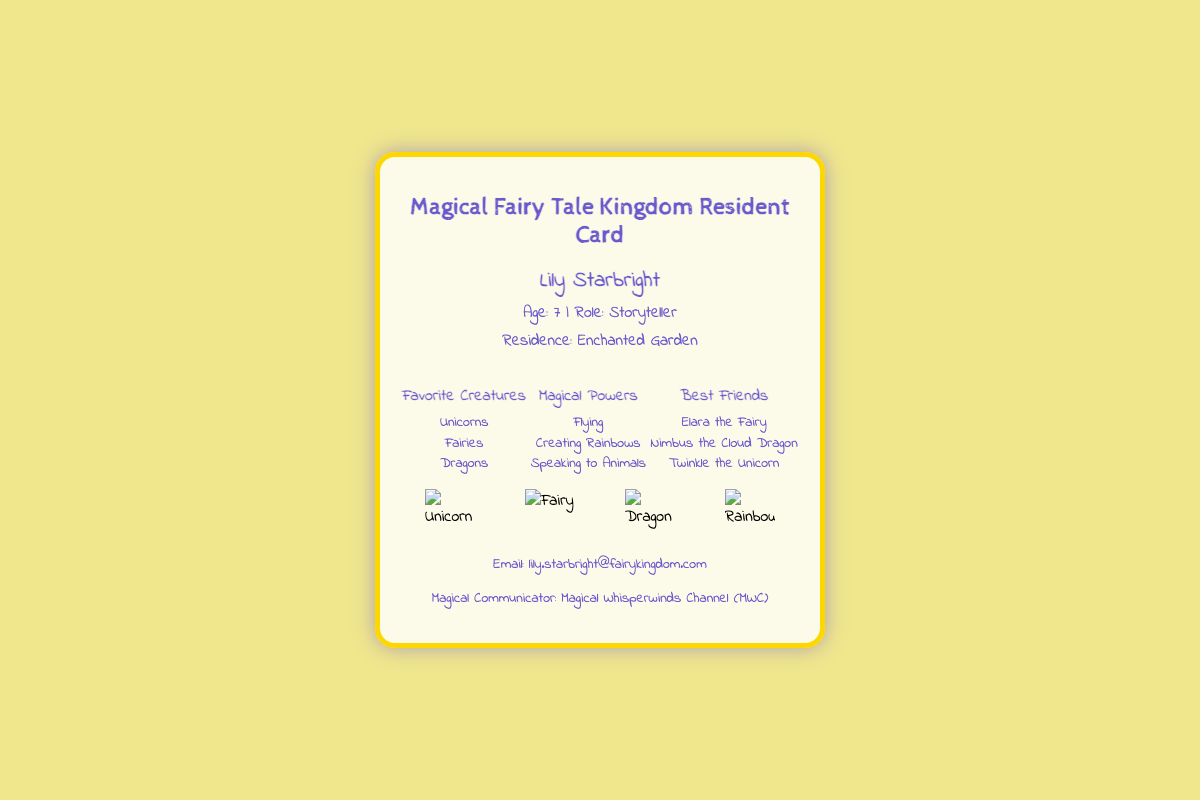What is the name of the resident? The name of the resident is listed prominently on the card.
Answer: Lily Starbright How old is Lily Starbright? The age of Lily is specifically mentioned in her resident information.
Answer: 7 What is Lily's role in the kingdom? The role of Lily is stated in the resident information section clearly.
Answer: Storyteller Where does Lily live? Lily's residence is noted under her personal details on the card.
Answer: Enchanted Garden What are Lily's favorite creatures? The card lists Lily's favorite creatures in a specific section.
Answer: Unicorns, Fairies, Dragons Which magical power allows Lily to fly? The document includes a list of magical powers Lily possesses.
Answer: Flying Who are Lily's best friends? The card features a section that mentions Lily's best friends.
Answer: Elara the Fairy, Nimbus the Cloud Dragon, Twinkle the Unicorn How can you contact Lily? The contact information includes details on how to reach Lily.
Answer: lily.starbright@fairykingdom.com What is the shape of the card? The document describes the design elements of the card.
Answer: Rounded What is included in the background of the card? The card features decorative elements in its background.
Answer: Sparkles, stars, fluffy clouds 